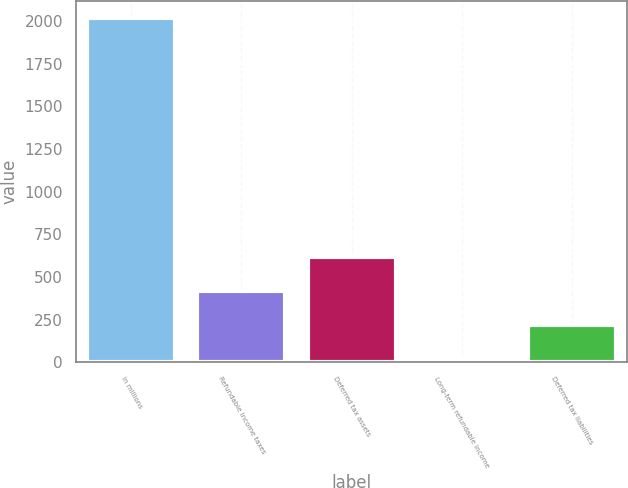Convert chart. <chart><loc_0><loc_0><loc_500><loc_500><bar_chart><fcel>In millions<fcel>Refundable income taxes<fcel>Deferred tax assets<fcel>Long-term refundable income<fcel>Deferred tax liabilities<nl><fcel>2015<fcel>417.4<fcel>617.1<fcel>18<fcel>217.7<nl></chart> 